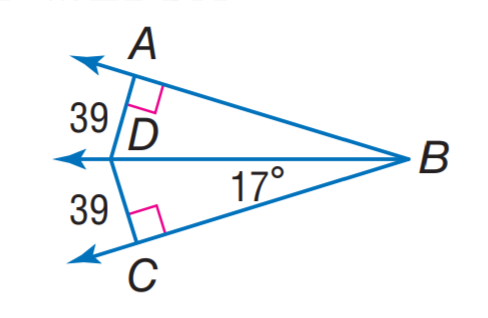Answer the mathemtical geometry problem and directly provide the correct option letter.
Question: Find m \angle D B A.
Choices: A: 17 B: 22 C: 32 D: 39 A 